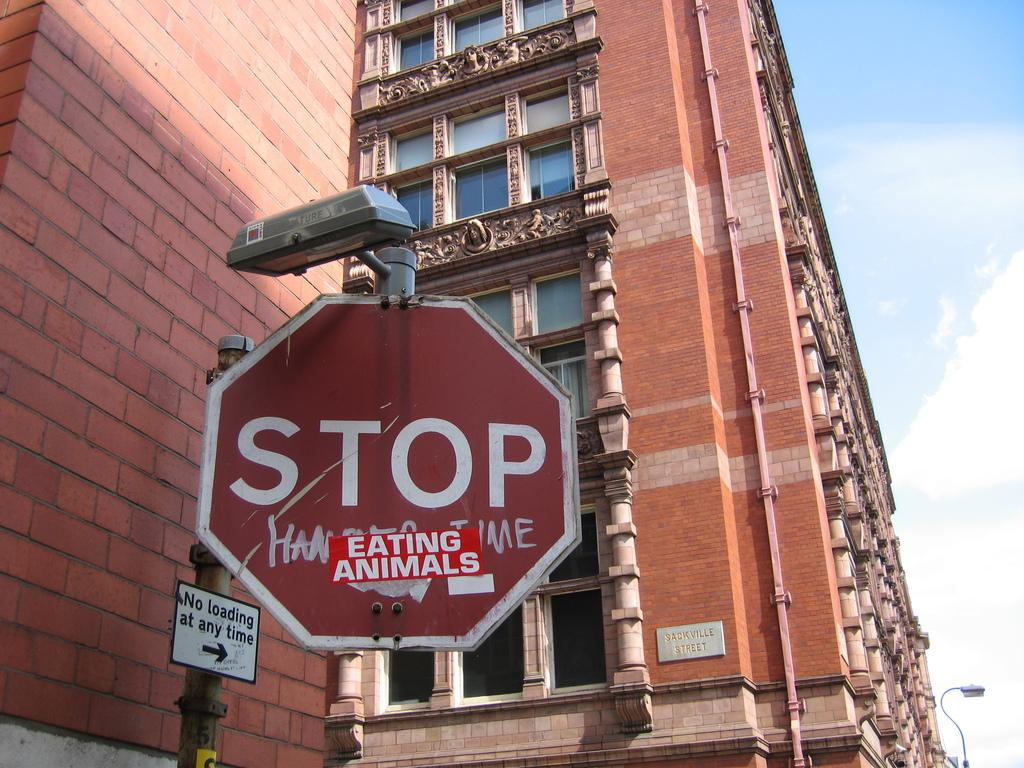<image>
Offer a succinct explanation of the picture presented. The stop sign has a sticker on it saying 'eating animals' below the word 'stop'. 